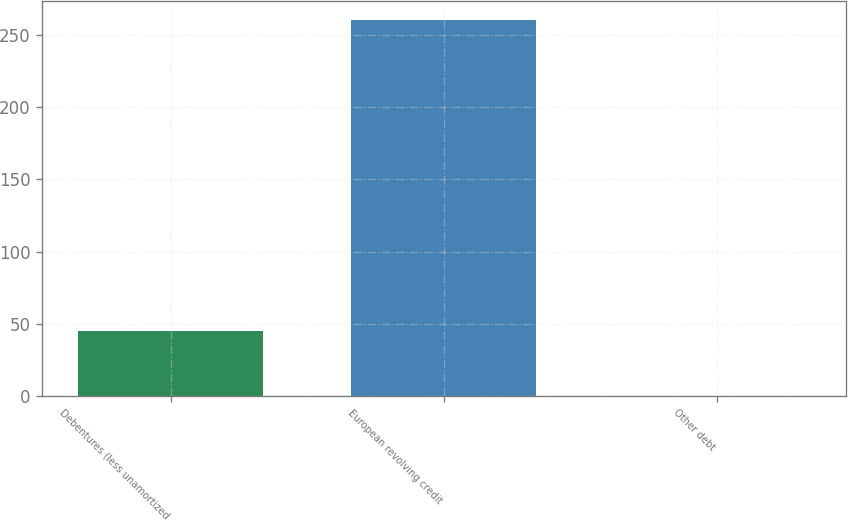Convert chart to OTSL. <chart><loc_0><loc_0><loc_500><loc_500><bar_chart><fcel>Debentures (less unamortized<fcel>European revolving credit<fcel>Other debt<nl><fcel>45.3<fcel>260.3<fcel>0.2<nl></chart> 